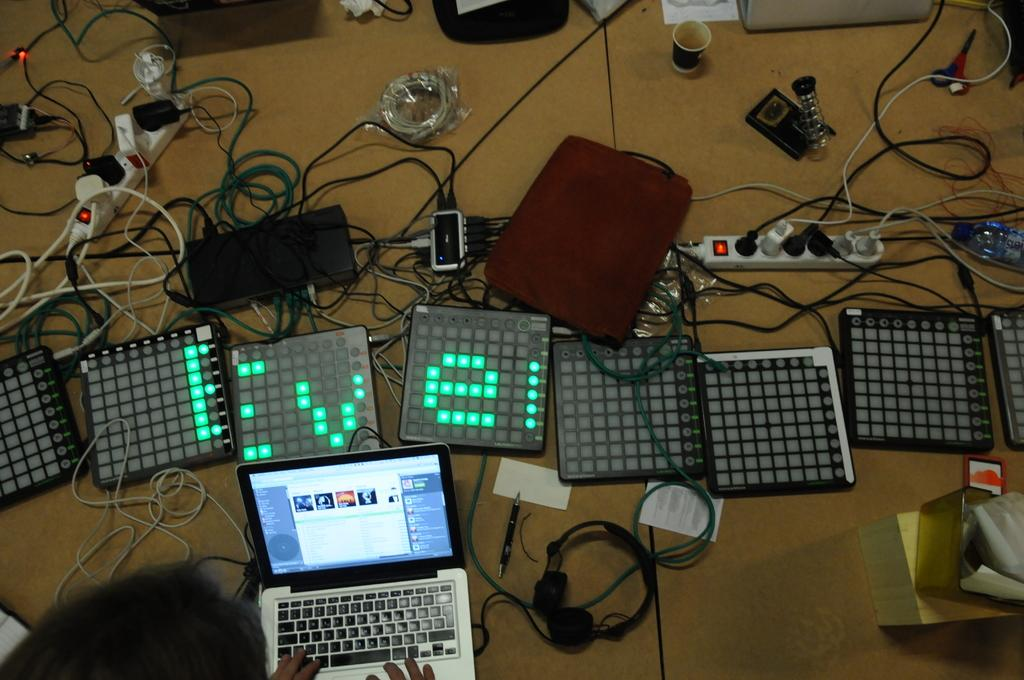<image>
Provide a brief description of the given image. A set of digital display boards reads Eve. 